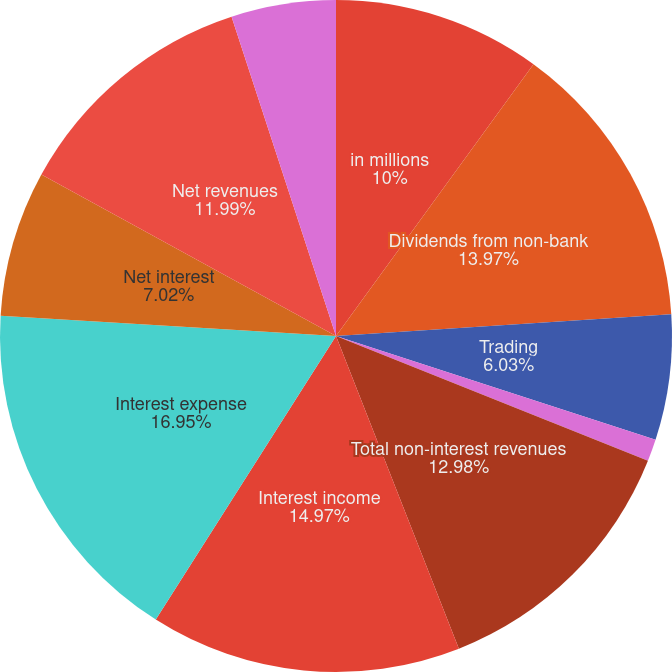Convert chart to OTSL. <chart><loc_0><loc_0><loc_500><loc_500><pie_chart><fcel>in millions<fcel>Dividends from non-bank<fcel>Trading<fcel>Other<fcel>Total non-interest revenues<fcel>Interest income<fcel>Interest expense<fcel>Net interest<fcel>Net revenues<fcel>Non-interest expenses<nl><fcel>10.0%<fcel>13.97%<fcel>6.03%<fcel>1.06%<fcel>12.98%<fcel>14.97%<fcel>16.95%<fcel>7.02%<fcel>11.99%<fcel>5.03%<nl></chart> 